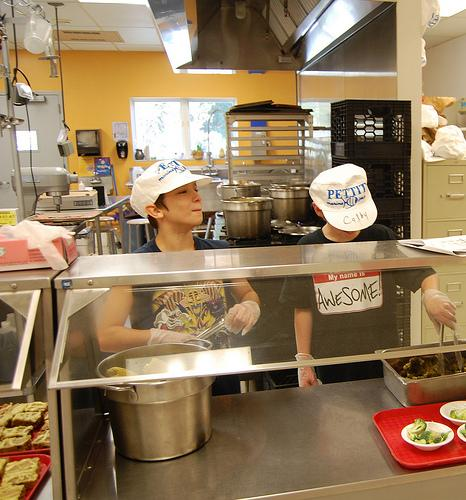What is the primary color theme of the background in the image? The wall in the background of the image is painted yellow. What is the emotion or atmosphere portrayed in the image? The atmosphere is focused, cooperative, and positive as the children work together in a soup kitchen. Describe the type of clothing worn by the individuals in the image. Both children are wearing white hats and black tops while also using clear sanitary gloves. Count and mention the number of trays and plates visible in the image. There is one red tray, one metal tray cart, and two plates visible in the image. In the image, are there any objects that have visible interactions or connections with other objects? If yes, what are they? Yes, there's broccoli in a dish, which indicates a connection between the dish and the vegetable. How many people are visible in the image? Two children are visible who are involved in cooking activities. How many different types of pots are visible in the image? There are three distinct cooking pots visible in the image. Provide a brief caption summarizing the content of the image. Two children wearing white hats and gloves work together at a soup kitchen, surrounded by various cooking utensils and ingredients. What is the main activity taking place in the image? Children working together in a soup kitchen, wearing white hats and gloves. List three specific objects you can see in this image. A stainless steel pot, a red cafeteria tray, and a pair of gloves. What object is seen near the counter in the image? A red tray Do the kids have any additional protective wear on their heads? Yes, they are wearing white hats. In the distant background, notice an elephant standing behind a tree. No, it's not mentioned in the image. How many pots are cascading over the stove? Pots are not cascading over the stove. There is one pot over a stove. What pastry items are set aside in the image? Pastries to the left What is the object made of metal near the people in the kitchen? Metal food display case Identify the dish involving broccoli. Bowl with broccoli What is the main color of the wall? Yellow 1) Woman wearing a red cap 3) Woman wearing a black cap Find and describe the secondary color of the wall. The secondary color is not provided. List the main items on the table, excluding the people. White bowl, bowl with broccoli, red cafeteria tray, plates, and lemons on a plate. Identify the tasks shown in the image and determine if they are involved in cooking or not. The tasks shown include wearing gloves, wearing caps, and working with pots. They are involved in cooking. What are the two kids doing together in this image? Working in a soup kitchen Try to spot the purple unicorn in the upper right corner of the image. There are no mentions of unicorns or any purple objects within the provided information, and the upper right corner does not have a listed object that could be mistaken for a unicorn. What is the color of the cap worn by the woman? White Describe the location of the lemons in the image. On a plate Is there a cabinet present in the image? If yes, specify its color. Yes, beige cabinet What does the boy in the image claim his name is? Awesome Observe the mosaic art of a famous historical figure on the back wall. The only mention of the wall in the provided information is that it is yellow, and there is no indication of any artwork, let alone one composed of mosaic or depicting a famous historical figure. Which of the following dishes is present in the image? 2) Broccoli What are the colors of the woman's cap and top? White cap, black top 